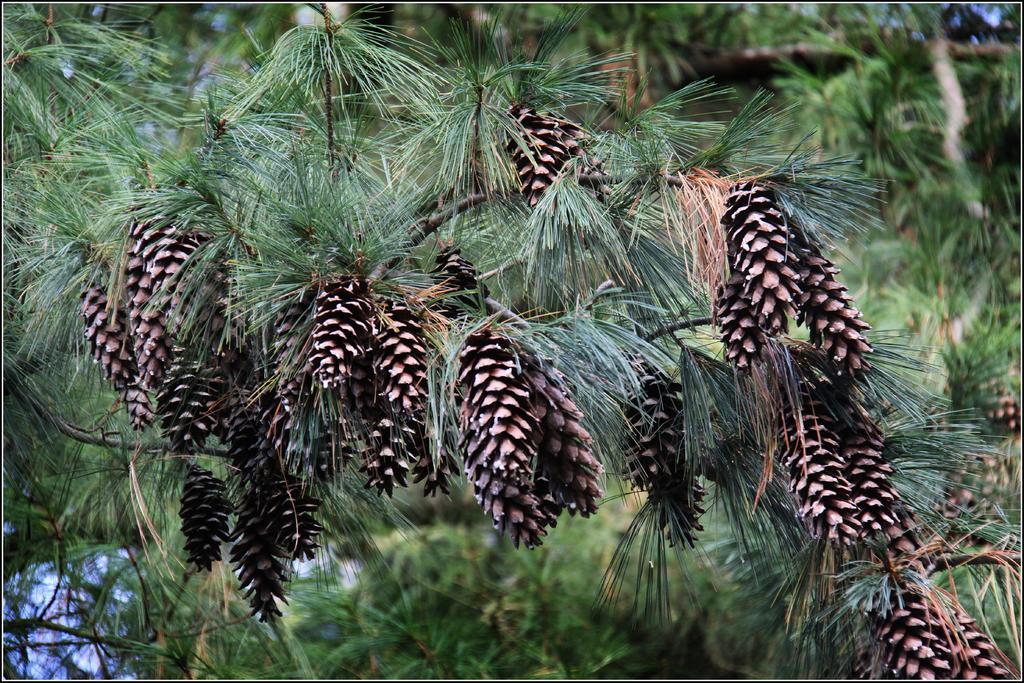Please provide a concise description of this image. In this picture we can see pines and few trees. 